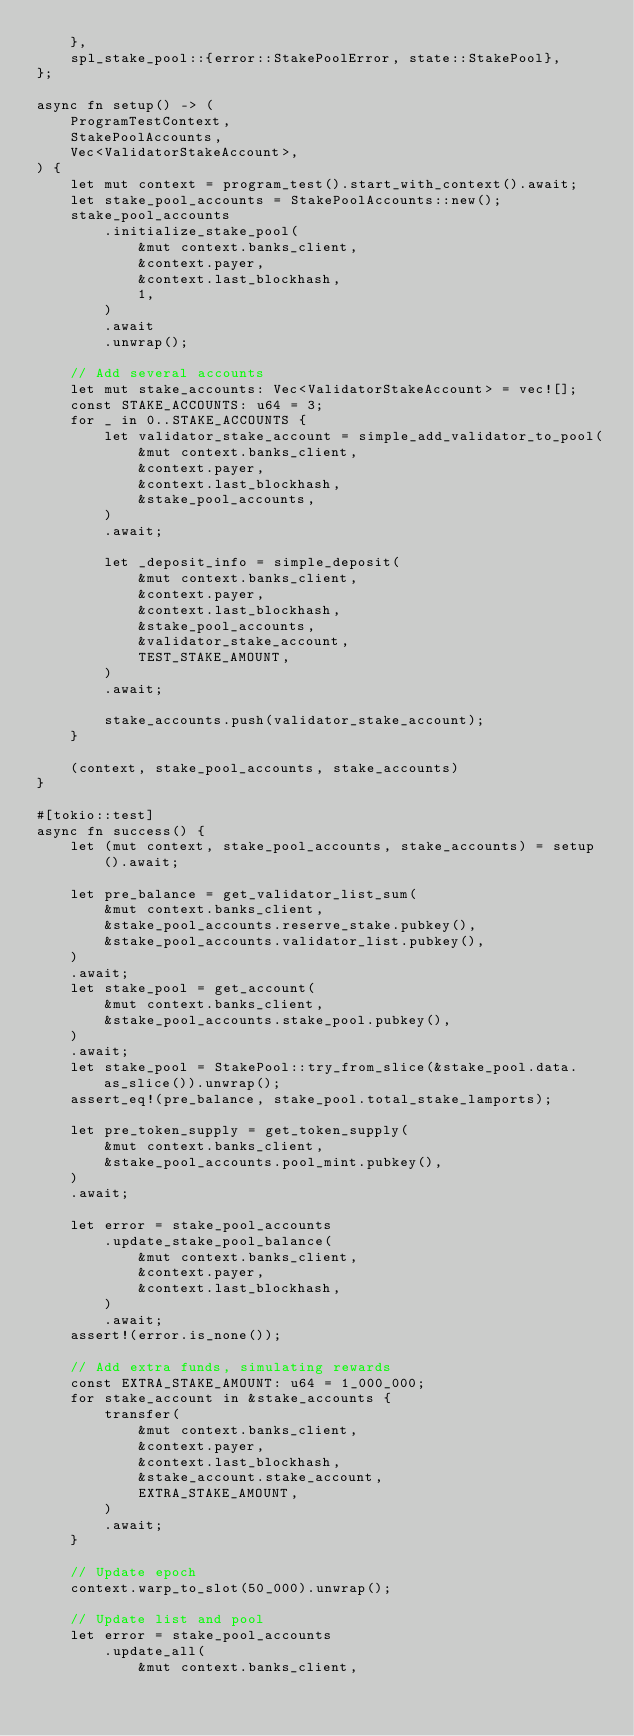<code> <loc_0><loc_0><loc_500><loc_500><_Rust_>    },
    spl_stake_pool::{error::StakePoolError, state::StakePool},
};

async fn setup() -> (
    ProgramTestContext,
    StakePoolAccounts,
    Vec<ValidatorStakeAccount>,
) {
    let mut context = program_test().start_with_context().await;
    let stake_pool_accounts = StakePoolAccounts::new();
    stake_pool_accounts
        .initialize_stake_pool(
            &mut context.banks_client,
            &context.payer,
            &context.last_blockhash,
            1,
        )
        .await
        .unwrap();

    // Add several accounts
    let mut stake_accounts: Vec<ValidatorStakeAccount> = vec![];
    const STAKE_ACCOUNTS: u64 = 3;
    for _ in 0..STAKE_ACCOUNTS {
        let validator_stake_account = simple_add_validator_to_pool(
            &mut context.banks_client,
            &context.payer,
            &context.last_blockhash,
            &stake_pool_accounts,
        )
        .await;

        let _deposit_info = simple_deposit(
            &mut context.banks_client,
            &context.payer,
            &context.last_blockhash,
            &stake_pool_accounts,
            &validator_stake_account,
            TEST_STAKE_AMOUNT,
        )
        .await;

        stake_accounts.push(validator_stake_account);
    }

    (context, stake_pool_accounts, stake_accounts)
}

#[tokio::test]
async fn success() {
    let (mut context, stake_pool_accounts, stake_accounts) = setup().await;

    let pre_balance = get_validator_list_sum(
        &mut context.banks_client,
        &stake_pool_accounts.reserve_stake.pubkey(),
        &stake_pool_accounts.validator_list.pubkey(),
    )
    .await;
    let stake_pool = get_account(
        &mut context.banks_client,
        &stake_pool_accounts.stake_pool.pubkey(),
    )
    .await;
    let stake_pool = StakePool::try_from_slice(&stake_pool.data.as_slice()).unwrap();
    assert_eq!(pre_balance, stake_pool.total_stake_lamports);

    let pre_token_supply = get_token_supply(
        &mut context.banks_client,
        &stake_pool_accounts.pool_mint.pubkey(),
    )
    .await;

    let error = stake_pool_accounts
        .update_stake_pool_balance(
            &mut context.banks_client,
            &context.payer,
            &context.last_blockhash,
        )
        .await;
    assert!(error.is_none());

    // Add extra funds, simulating rewards
    const EXTRA_STAKE_AMOUNT: u64 = 1_000_000;
    for stake_account in &stake_accounts {
        transfer(
            &mut context.banks_client,
            &context.payer,
            &context.last_blockhash,
            &stake_account.stake_account,
            EXTRA_STAKE_AMOUNT,
        )
        .await;
    }

    // Update epoch
    context.warp_to_slot(50_000).unwrap();

    // Update list and pool
    let error = stake_pool_accounts
        .update_all(
            &mut context.banks_client,</code> 